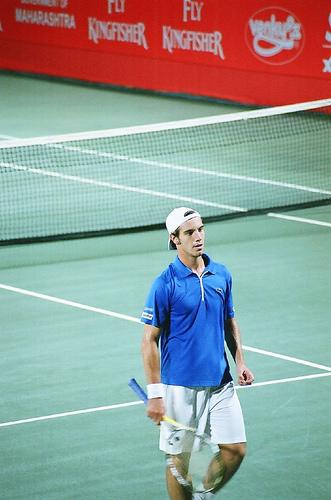What is the color of the barrier surrounding the tennis court? The barrier color is red. What could be the purpose of the red and white advertisement banners in the stadium? The red and white advertisement banners are for promotional purposes during a tennis match or event. Specify the color and location of the wrist band on the tennis player. The wrist band is white and located on the tennis player's left wrist. Identify the outfit of the tennis player and any accessories he is wearing. The tennis player is wearing a blue short sleeved shirt, white shorts, a white hat worn backwards, and a white wrist band. Describe the appearance of the tennis court and its environment. The tennis court has a green surface with white lines, a stretched tennis net, and a red wall on the side. What is the color and position of the tennis player's hat? The tennis player's hat is white and worn backwards. What activity is the young man in the image participating in? The young man is playing tennis on a tennis court. Provide a description of the colors and details on the tennis racket. The tennis racket has a blue and yellow design with a blue handle. Mention one unique feature displayed on the tennis player's shirt. There is an alligator logo on the tennis player's shirt. What is the predominant color of the ground on the tennis court? The predominant color of the ground is green. 